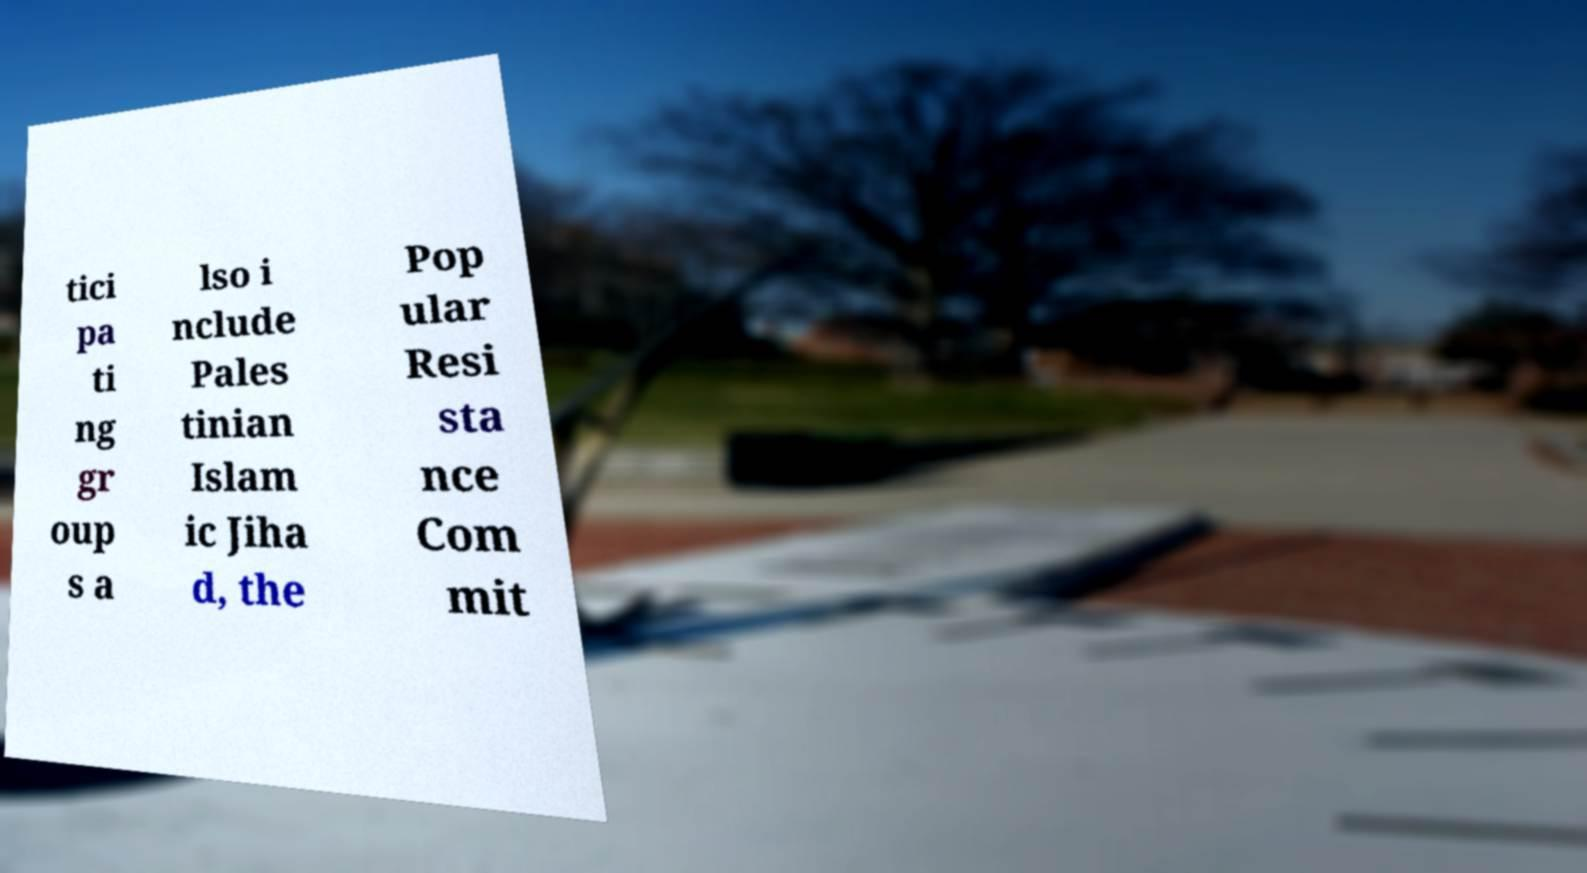Can you read and provide the text displayed in the image?This photo seems to have some interesting text. Can you extract and type it out for me? tici pa ti ng gr oup s a lso i nclude Pales tinian Islam ic Jiha d, the Pop ular Resi sta nce Com mit 